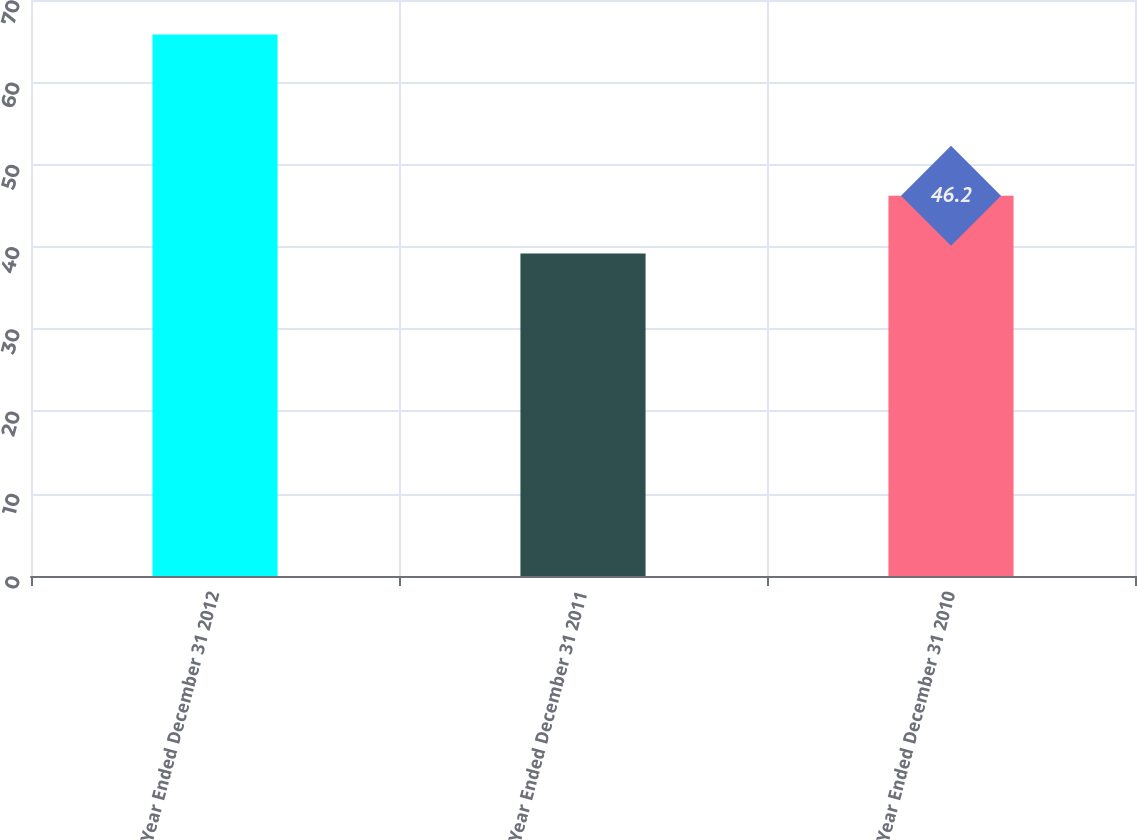<chart> <loc_0><loc_0><loc_500><loc_500><bar_chart><fcel>Year Ended December 31 2012<fcel>Year Ended December 31 2011<fcel>Year Ended December 31 2010<nl><fcel>65.8<fcel>39.2<fcel>46.2<nl></chart> 